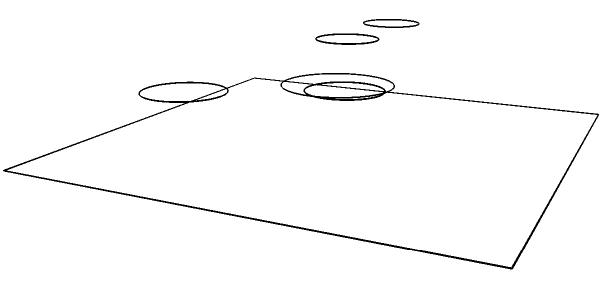From a guitarist's perspective at the front of the stage, which of the following descriptions accurately represents the drum kit setup shown in the image?

A) The hi-hat is on the left, with the crash cymbal on the right
B) The floor tom is on the left side, near the bass drum
C) The snare drum is positioned between the two rack toms
D) The bass drum is centered, with the snare drum slightly to its right Let's analyze the drum kit setup step-by-step:

1. Bass drum: Located at the center of the kit, as seen from our perspective.

2. Snare drum: Positioned slightly to the right of the bass drum.

3. Tom-toms (rack toms): Two smaller drums are visible above and slightly to the left and right of the bass drum.

4. Floor tom: Located on the right side of the kit, away from the bass drum.

5. Crash cymbal: Positioned on the right side of the kit, above the floor tom.

6. Hi-hat: Located on the left side of the kit.

Comparing these observations to the given options:

A) Correct - The hi-hat is indeed on the left, with the crash cymbal on the right.
B) Incorrect - The floor tom is on the right side, not the left.
C) Incorrect - The snare drum is not between the two rack toms.
D) Correct - The bass drum is centered, with the snare drum slightly to its right.

Since option A is the only completely accurate statement, it is the correct answer.
Answer: A 